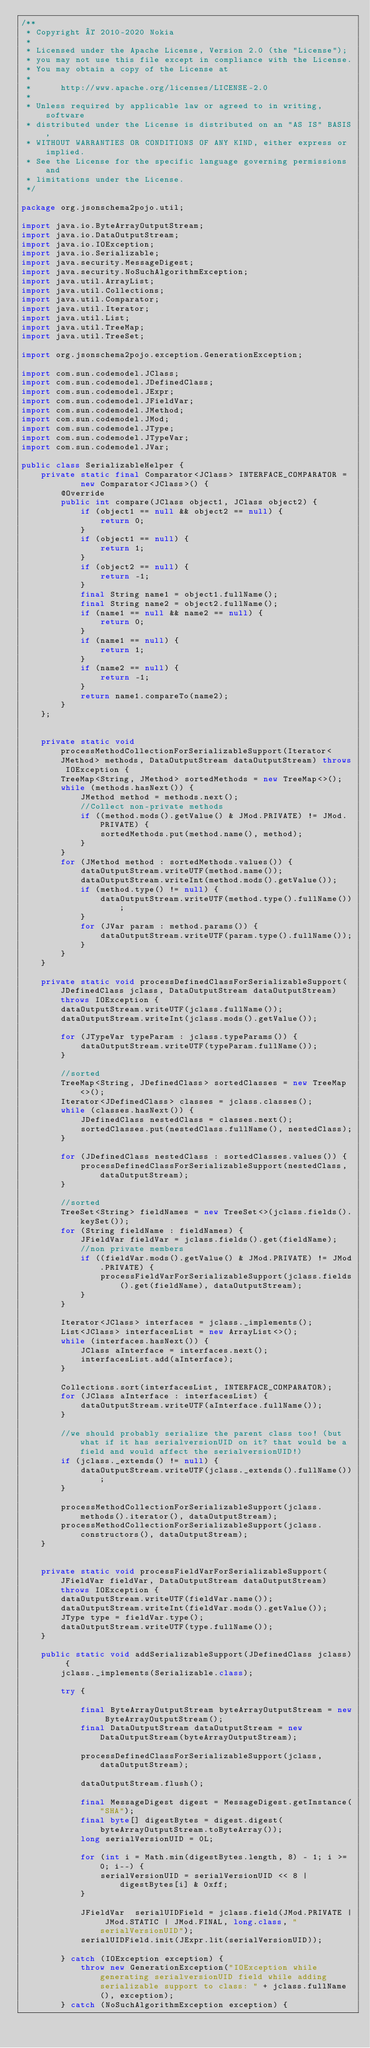<code> <loc_0><loc_0><loc_500><loc_500><_Java_>/**
 * Copyright © 2010-2020 Nokia
 *
 * Licensed under the Apache License, Version 2.0 (the "License");
 * you may not use this file except in compliance with the License.
 * You may obtain a copy of the License at
 *
 *      http://www.apache.org/licenses/LICENSE-2.0
 *
 * Unless required by applicable law or agreed to in writing, software
 * distributed under the License is distributed on an "AS IS" BASIS,
 * WITHOUT WARRANTIES OR CONDITIONS OF ANY KIND, either express or implied.
 * See the License for the specific language governing permissions and
 * limitations under the License.
 */

package org.jsonschema2pojo.util;

import java.io.ByteArrayOutputStream;
import java.io.DataOutputStream;
import java.io.IOException;
import java.io.Serializable;
import java.security.MessageDigest;
import java.security.NoSuchAlgorithmException;
import java.util.ArrayList;
import java.util.Collections;
import java.util.Comparator;
import java.util.Iterator;
import java.util.List;
import java.util.TreeMap;
import java.util.TreeSet;

import org.jsonschema2pojo.exception.GenerationException;

import com.sun.codemodel.JClass;
import com.sun.codemodel.JDefinedClass;
import com.sun.codemodel.JExpr;
import com.sun.codemodel.JFieldVar;
import com.sun.codemodel.JMethod;
import com.sun.codemodel.JMod;
import com.sun.codemodel.JType;
import com.sun.codemodel.JTypeVar;
import com.sun.codemodel.JVar;

public class SerializableHelper {
    private static final Comparator<JClass> INTERFACE_COMPARATOR =
            new Comparator<JClass>() {
        @Override
        public int compare(JClass object1, JClass object2) {
            if (object1 == null && object2 == null) {
                return 0;
            }
            if (object1 == null) {
                return 1;
            }
            if (object2 == null) {
                return -1;
            }
            final String name1 = object1.fullName();
            final String name2 = object2.fullName();
            if (name1 == null && name2 == null) {
                return 0;
            }
            if (name1 == null) {
                return 1;
            }
            if (name2 == null) {
                return -1;
            }
            return name1.compareTo(name2);
        }
    };


    private static void processMethodCollectionForSerializableSupport(Iterator<JMethod> methods, DataOutputStream dataOutputStream) throws IOException {
        TreeMap<String, JMethod> sortedMethods = new TreeMap<>();
        while (methods.hasNext()) {
            JMethod method = methods.next();
            //Collect non-private methods
            if ((method.mods().getValue() & JMod.PRIVATE) != JMod.PRIVATE) {
                sortedMethods.put(method.name(), method);
            }
        }
        for (JMethod method : sortedMethods.values()) {
            dataOutputStream.writeUTF(method.name());
            dataOutputStream.writeInt(method.mods().getValue());
            if (method.type() != null) {
                dataOutputStream.writeUTF(method.type().fullName());
            }
            for (JVar param : method.params()) {
                dataOutputStream.writeUTF(param.type().fullName());
            }
        }
    }

    private static void processDefinedClassForSerializableSupport(JDefinedClass jclass, DataOutputStream dataOutputStream) throws IOException {
        dataOutputStream.writeUTF(jclass.fullName());
        dataOutputStream.writeInt(jclass.mods().getValue());

        for (JTypeVar typeParam : jclass.typeParams()) {
            dataOutputStream.writeUTF(typeParam.fullName());
        }

        //sorted
        TreeMap<String, JDefinedClass> sortedClasses = new TreeMap<>();
        Iterator<JDefinedClass> classes = jclass.classes();
        while (classes.hasNext()) {
            JDefinedClass nestedClass = classes.next();
            sortedClasses.put(nestedClass.fullName(), nestedClass);
        }

        for (JDefinedClass nestedClass : sortedClasses.values()) {
            processDefinedClassForSerializableSupport(nestedClass, dataOutputStream);
        }

        //sorted
        TreeSet<String> fieldNames = new TreeSet<>(jclass.fields().keySet());
        for (String fieldName : fieldNames) {
            JFieldVar fieldVar = jclass.fields().get(fieldName);
            //non private members
            if ((fieldVar.mods().getValue() & JMod.PRIVATE) != JMod.PRIVATE) {
                processFieldVarForSerializableSupport(jclass.fields().get(fieldName), dataOutputStream);
            }
        }

        Iterator<JClass> interfaces = jclass._implements();
        List<JClass> interfacesList = new ArrayList<>();
        while (interfaces.hasNext()) {
            JClass aInterface = interfaces.next();
            interfacesList.add(aInterface);
        }

        Collections.sort(interfacesList, INTERFACE_COMPARATOR);
        for (JClass aInterface : interfacesList) {
            dataOutputStream.writeUTF(aInterface.fullName());
        }

        //we should probably serialize the parent class too! (but what if it has serialversionUID on it? that would be a field and would affect the serialversionUID!)
        if (jclass._extends() != null) {
            dataOutputStream.writeUTF(jclass._extends().fullName());
        }

        processMethodCollectionForSerializableSupport(jclass.methods().iterator(), dataOutputStream);
        processMethodCollectionForSerializableSupport(jclass.constructors(), dataOutputStream);
    }


    private static void processFieldVarForSerializableSupport(JFieldVar fieldVar, DataOutputStream dataOutputStream) throws IOException {
        dataOutputStream.writeUTF(fieldVar.name());
        dataOutputStream.writeInt(fieldVar.mods().getValue());
        JType type = fieldVar.type();
        dataOutputStream.writeUTF(type.fullName());
    }

    public static void addSerializableSupport(JDefinedClass jclass) {
        jclass._implements(Serializable.class);

        try {

            final ByteArrayOutputStream byteArrayOutputStream = new ByteArrayOutputStream();
            final DataOutputStream dataOutputStream = new DataOutputStream(byteArrayOutputStream);

            processDefinedClassForSerializableSupport(jclass, dataOutputStream);

            dataOutputStream.flush();

            final MessageDigest digest = MessageDigest.getInstance("SHA");
            final byte[] digestBytes = digest.digest(byteArrayOutputStream.toByteArray());
            long serialVersionUID = 0L;

            for (int i = Math.min(digestBytes.length, 8) - 1; i >= 0; i--) {
                serialVersionUID = serialVersionUID << 8 | digestBytes[i] & 0xff;
            }

            JFieldVar  serialUIDField = jclass.field(JMod.PRIVATE | JMod.STATIC | JMod.FINAL, long.class, "serialVersionUID");
            serialUIDField.init(JExpr.lit(serialVersionUID));

        } catch (IOException exception) {
            throw new GenerationException("IOException while generating serialversionUID field while adding serializable support to class: " + jclass.fullName(), exception);
        } catch (NoSuchAlgorithmException exception) {</code> 